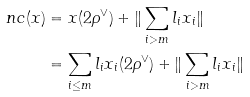<formula> <loc_0><loc_0><loc_500><loc_500>\ n c ( x ) & = x ( 2 \rho ^ { \vee } ) + \| \sum _ { i > m } l _ { i } x _ { i } \| \\ & = \sum _ { i \leq m } l _ { i } x _ { i } ( 2 \rho ^ { \vee } ) + \| \sum _ { i > m } l _ { i } x _ { i } \| \\</formula> 